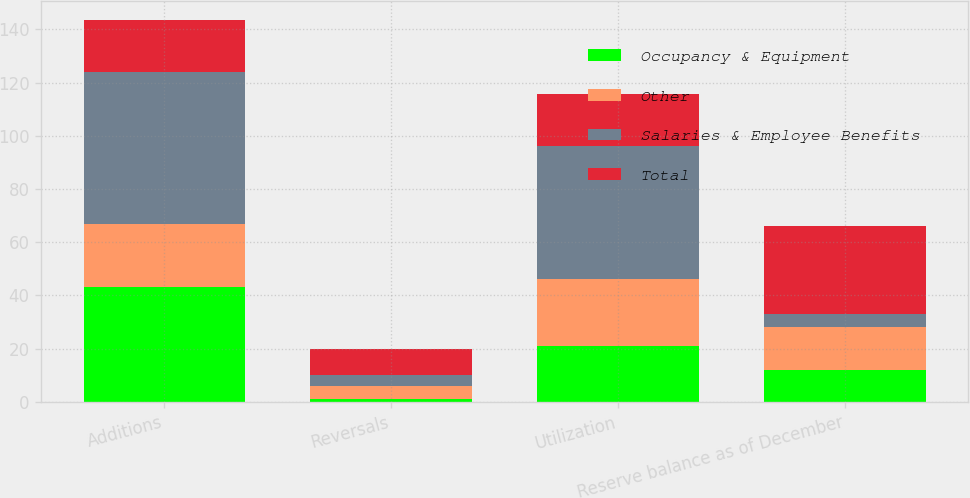Convert chart to OTSL. <chart><loc_0><loc_0><loc_500><loc_500><stacked_bar_chart><ecel><fcel>Additions<fcel>Reversals<fcel>Utilization<fcel>Reserve balance as of December<nl><fcel>Occupancy & Equipment<fcel>43<fcel>1<fcel>21<fcel>12<nl><fcel>Other<fcel>24<fcel>5<fcel>25<fcel>16<nl><fcel>Salaries & Employee Benefits<fcel>57<fcel>4<fcel>50<fcel>5<nl><fcel>Total<fcel>19.5<fcel>10<fcel>19.5<fcel>33<nl></chart> 